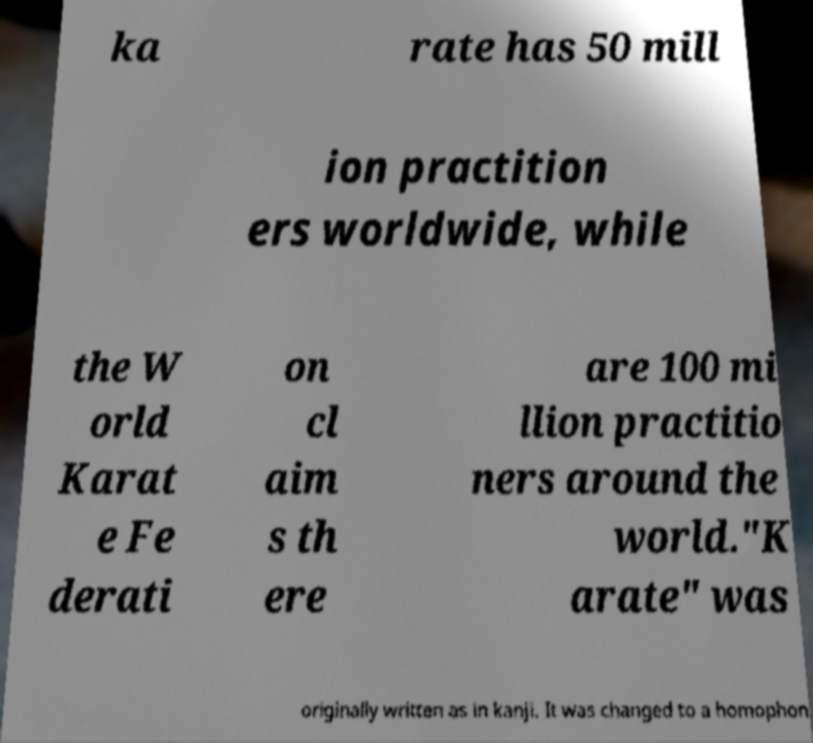For documentation purposes, I need the text within this image transcribed. Could you provide that? ka rate has 50 mill ion practition ers worldwide, while the W orld Karat e Fe derati on cl aim s th ere are 100 mi llion practitio ners around the world."K arate" was originally written as in kanji. It was changed to a homophon 